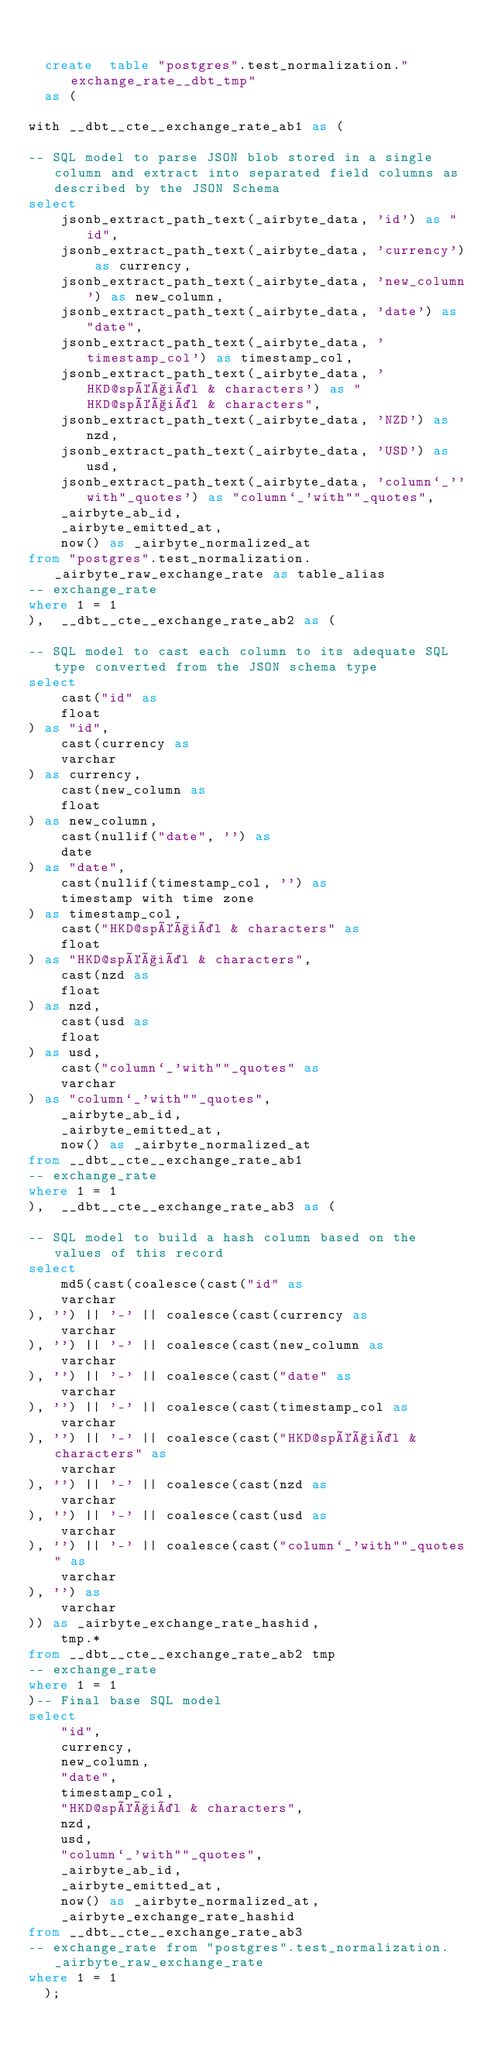Convert code to text. <code><loc_0><loc_0><loc_500><loc_500><_SQL_>

  create  table "postgres".test_normalization."exchange_rate__dbt_tmp"
  as (
    
with __dbt__cte__exchange_rate_ab1 as (

-- SQL model to parse JSON blob stored in a single column and extract into separated field columns as described by the JSON Schema
select
    jsonb_extract_path_text(_airbyte_data, 'id') as "id",
    jsonb_extract_path_text(_airbyte_data, 'currency') as currency,
    jsonb_extract_path_text(_airbyte_data, 'new_column') as new_column,
    jsonb_extract_path_text(_airbyte_data, 'date') as "date",
    jsonb_extract_path_text(_airbyte_data, 'timestamp_col') as timestamp_col,
    jsonb_extract_path_text(_airbyte_data, 'HKD@spéçiäl & characters') as "HKD@spéçiäl & characters",
    jsonb_extract_path_text(_airbyte_data, 'NZD') as nzd,
    jsonb_extract_path_text(_airbyte_data, 'USD') as usd,
    jsonb_extract_path_text(_airbyte_data, 'column`_''with"_quotes') as "column`_'with""_quotes",
    _airbyte_ab_id,
    _airbyte_emitted_at,
    now() as _airbyte_normalized_at
from "postgres".test_normalization._airbyte_raw_exchange_rate as table_alias
-- exchange_rate
where 1 = 1
),  __dbt__cte__exchange_rate_ab2 as (

-- SQL model to cast each column to its adequate SQL type converted from the JSON schema type
select
    cast("id" as 
    float
) as "id",
    cast(currency as 
    varchar
) as currency,
    cast(new_column as 
    float
) as new_column,
    cast(nullif("date", '') as 
    date
) as "date",
    cast(nullif(timestamp_col, '') as 
    timestamp with time zone
) as timestamp_col,
    cast("HKD@spéçiäl & characters" as 
    float
) as "HKD@spéçiäl & characters",
    cast(nzd as 
    float
) as nzd,
    cast(usd as 
    float
) as usd,
    cast("column`_'with""_quotes" as 
    varchar
) as "column`_'with""_quotes",
    _airbyte_ab_id,
    _airbyte_emitted_at,
    now() as _airbyte_normalized_at
from __dbt__cte__exchange_rate_ab1
-- exchange_rate
where 1 = 1
),  __dbt__cte__exchange_rate_ab3 as (

-- SQL model to build a hash column based on the values of this record
select
    md5(cast(coalesce(cast("id" as 
    varchar
), '') || '-' || coalesce(cast(currency as 
    varchar
), '') || '-' || coalesce(cast(new_column as 
    varchar
), '') || '-' || coalesce(cast("date" as 
    varchar
), '') || '-' || coalesce(cast(timestamp_col as 
    varchar
), '') || '-' || coalesce(cast("HKD@spéçiäl & characters" as 
    varchar
), '') || '-' || coalesce(cast(nzd as 
    varchar
), '') || '-' || coalesce(cast(usd as 
    varchar
), '') || '-' || coalesce(cast("column`_'with""_quotes" as 
    varchar
), '') as 
    varchar
)) as _airbyte_exchange_rate_hashid,
    tmp.*
from __dbt__cte__exchange_rate_ab2 tmp
-- exchange_rate
where 1 = 1
)-- Final base SQL model
select
    "id",
    currency,
    new_column,
    "date",
    timestamp_col,
    "HKD@spéçiäl & characters",
    nzd,
    usd,
    "column`_'with""_quotes",
    _airbyte_ab_id,
    _airbyte_emitted_at,
    now() as _airbyte_normalized_at,
    _airbyte_exchange_rate_hashid
from __dbt__cte__exchange_rate_ab3
-- exchange_rate from "postgres".test_normalization._airbyte_raw_exchange_rate
where 1 = 1
  );</code> 